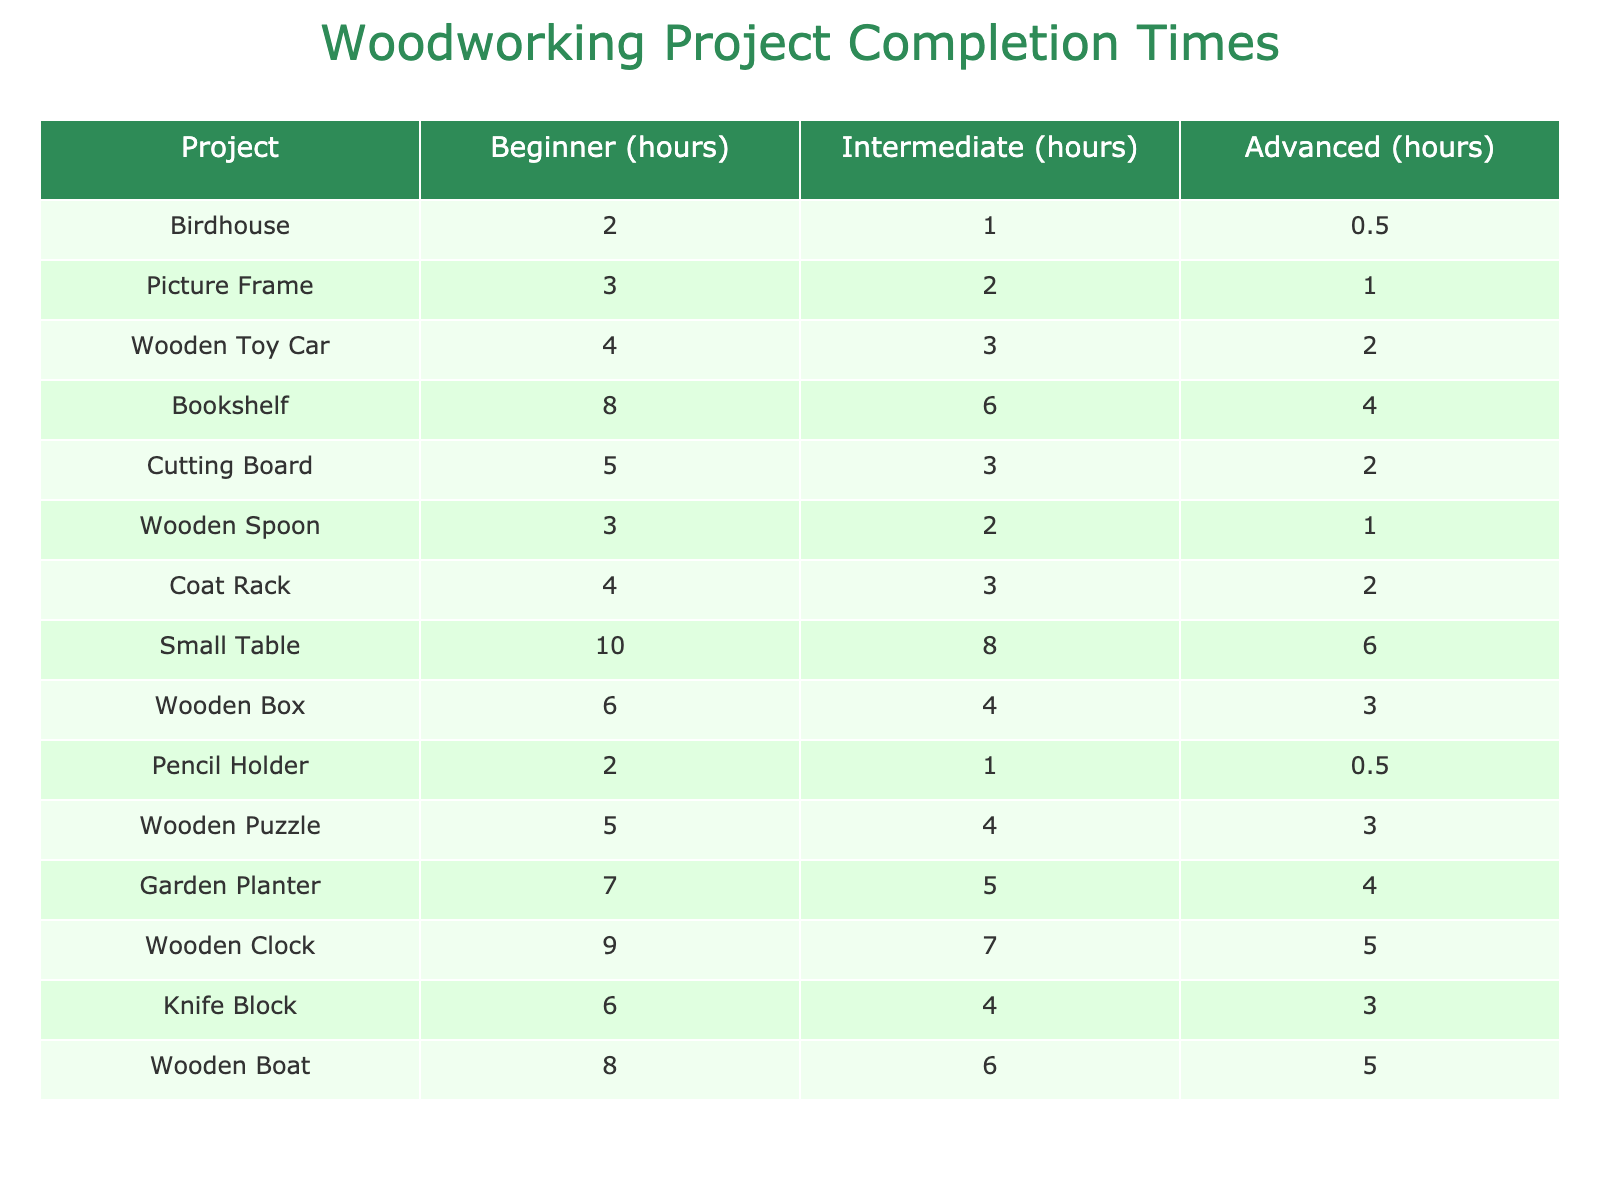What is the completion time for building a birdhouse at the beginner level? The table shows that the beginner completion time for a birdhouse is listed under the "Beginner" column next to its name, which is 2 hours.
Answer: 2 hours Which project takes the most time to complete at the advanced level? By looking at the advanced column, the project with the highest value is the "Small Table" with a completion time of 6 hours.
Answer: Small Table How long does it take to complete a wooden toy car compared to a picture frame at the intermediate level? For the wooden toy car, the time is 3 hours, and for the picture frame, it is 2 hours. Comparing the two: 3 - 2 = 1 hour difference, thus the wooden toy car takes 1 hour more than the picture frame.
Answer: 1 hour Is it true that a wooden clock takes longer to complete than a garden planter at the beginner level? The completion time for a wooden clock is 9 hours and for a garden planter is 7 hours, so 9 hours is greater than 7 hours. Therefore, it is true that the wooden clock takes longer.
Answer: True What is the average completion time for all beginner level projects? The total completion time for beginner projects is (2 + 3 + 4 + 8 + 5 + 3 + 4 + 10 + 6 + 2 + 5 + 7 + 9 + 6 + 8) = 81 hours. There are 15 projects, so the average is 81/15 = 5.4 hours.
Answer: 5.4 hours Which project has the least completion time at the advanced level? The advanced times are: 0.5, 1, 2, 4, 2, 1, 2, 6, 3, 0.5, 3, 4, 5, 3, 5. The least time is 0.5 hours, corresponding to both "Birdhouse" and "Pencil Holder."
Answer: Birdhouse and Pencil Holder How much more time does it take to complete a bookshelf compared to a cutting board at the intermediate level? The bookshelf takes 6 hours and the cutting board takes 3 hours. The difference is 6 - 3 = 3 hours, meaning the bookshelf takes 3 hours more than the cutting board.
Answer: 3 hours Which two projects at the beginner level have the same completion time? By reviewing the beginner times, the projects "Pencil Holder" and "Birdhouse" both take 2 hours to complete.
Answer: Pencil Holder and Birdhouse If you want to complete three beginner projects, what is the minimum possible time? The shortest times in the beginner category are 2 + 2 + 3 hours from "Birdhouse," "Pencil Holder," and "Wooden Spoon," totaling 7 hours.
Answer: 7 hours What project takes the least time to complete at the intermediate level? For intermediate times, the least is 1 hour, which corresponds to the "Picture Frame" and "Wooden Spoon."
Answer: Picture Frame and Wooden Spoon 